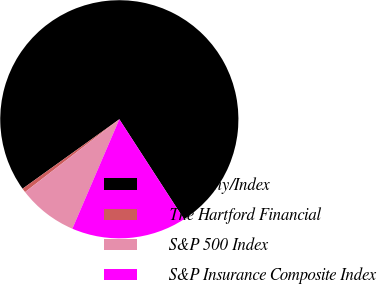Convert chart to OTSL. <chart><loc_0><loc_0><loc_500><loc_500><pie_chart><fcel>Company/Index<fcel>The Hartford Financial<fcel>S&P 500 Index<fcel>S&P Insurance Composite Index<nl><fcel>75.76%<fcel>0.56%<fcel>8.08%<fcel>15.6%<nl></chart> 